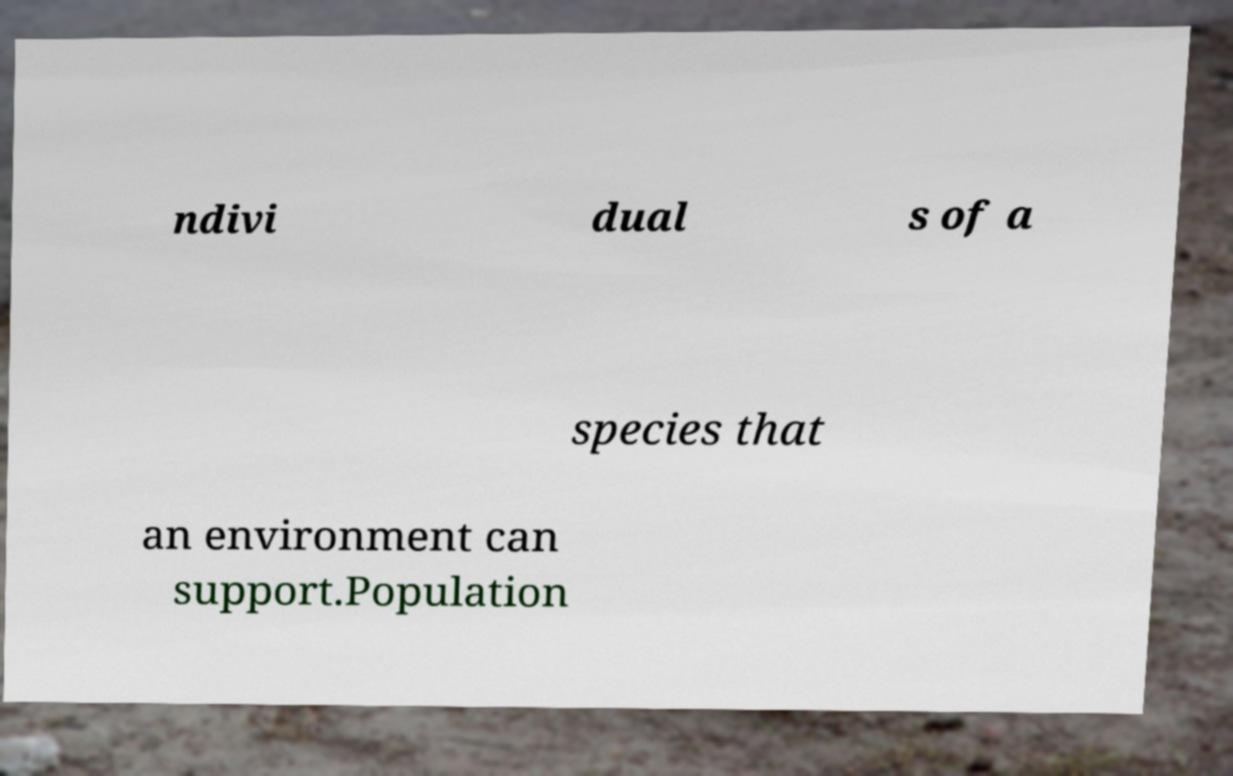I need the written content from this picture converted into text. Can you do that? ndivi dual s of a species that an environment can support.Population 